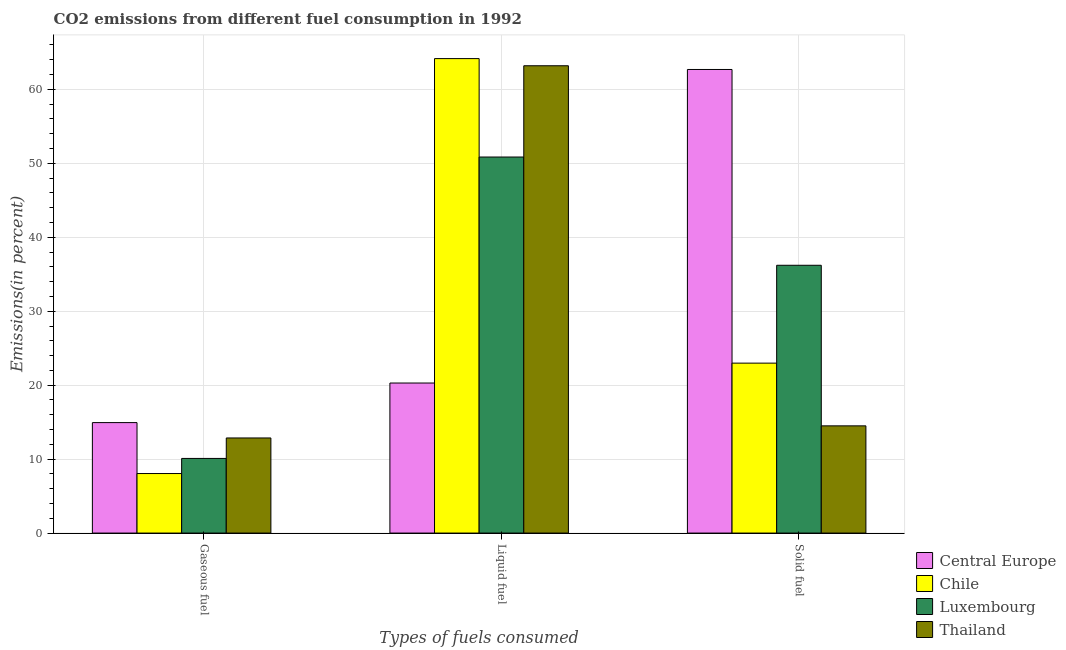How many different coloured bars are there?
Your response must be concise. 4. Are the number of bars per tick equal to the number of legend labels?
Your response must be concise. Yes. How many bars are there on the 2nd tick from the left?
Keep it short and to the point. 4. How many bars are there on the 3rd tick from the right?
Your answer should be compact. 4. What is the label of the 1st group of bars from the left?
Keep it short and to the point. Gaseous fuel. What is the percentage of solid fuel emission in Luxembourg?
Offer a very short reply. 36.21. Across all countries, what is the maximum percentage of gaseous fuel emission?
Make the answer very short. 14.94. Across all countries, what is the minimum percentage of solid fuel emission?
Offer a very short reply. 14.5. In which country was the percentage of gaseous fuel emission maximum?
Provide a succinct answer. Central Europe. In which country was the percentage of liquid fuel emission minimum?
Provide a succinct answer. Central Europe. What is the total percentage of liquid fuel emission in the graph?
Offer a terse response. 198.49. What is the difference between the percentage of solid fuel emission in Chile and that in Central Europe?
Offer a terse response. -39.71. What is the difference between the percentage of liquid fuel emission in Chile and the percentage of solid fuel emission in Thailand?
Give a very brief answer. 49.66. What is the average percentage of solid fuel emission per country?
Provide a short and direct response. 34.09. What is the difference between the percentage of liquid fuel emission and percentage of gaseous fuel emission in Chile?
Give a very brief answer. 56.11. In how many countries, is the percentage of solid fuel emission greater than 54 %?
Offer a terse response. 1. What is the ratio of the percentage of gaseous fuel emission in Chile to that in Central Europe?
Provide a short and direct response. 0.54. Is the percentage of liquid fuel emission in Chile less than that in Central Europe?
Offer a very short reply. No. What is the difference between the highest and the second highest percentage of solid fuel emission?
Offer a terse response. 26.48. What is the difference between the highest and the lowest percentage of gaseous fuel emission?
Provide a succinct answer. 6.89. Is the sum of the percentage of solid fuel emission in Luxembourg and Chile greater than the maximum percentage of gaseous fuel emission across all countries?
Offer a very short reply. Yes. What does the 1st bar from the left in Gaseous fuel represents?
Offer a terse response. Central Europe. What does the 4th bar from the right in Solid fuel represents?
Keep it short and to the point. Central Europe. Is it the case that in every country, the sum of the percentage of gaseous fuel emission and percentage of liquid fuel emission is greater than the percentage of solid fuel emission?
Your answer should be compact. No. How many countries are there in the graph?
Provide a succinct answer. 4. What is the difference between two consecutive major ticks on the Y-axis?
Provide a short and direct response. 10. Are the values on the major ticks of Y-axis written in scientific E-notation?
Your answer should be compact. No. Does the graph contain any zero values?
Provide a short and direct response. No. Does the graph contain grids?
Your answer should be very brief. Yes. Where does the legend appear in the graph?
Provide a succinct answer. Bottom right. How many legend labels are there?
Offer a very short reply. 4. How are the legend labels stacked?
Make the answer very short. Vertical. What is the title of the graph?
Offer a very short reply. CO2 emissions from different fuel consumption in 1992. Does "Ireland" appear as one of the legend labels in the graph?
Offer a very short reply. No. What is the label or title of the X-axis?
Make the answer very short. Types of fuels consumed. What is the label or title of the Y-axis?
Your response must be concise. Emissions(in percent). What is the Emissions(in percent) of Central Europe in Gaseous fuel?
Provide a succinct answer. 14.94. What is the Emissions(in percent) of Chile in Gaseous fuel?
Provide a short and direct response. 8.05. What is the Emissions(in percent) in Luxembourg in Gaseous fuel?
Provide a succinct answer. 10.09. What is the Emissions(in percent) in Thailand in Gaseous fuel?
Keep it short and to the point. 12.86. What is the Emissions(in percent) of Central Europe in Liquid fuel?
Ensure brevity in your answer.  20.29. What is the Emissions(in percent) in Chile in Liquid fuel?
Your answer should be very brief. 64.16. What is the Emissions(in percent) of Luxembourg in Liquid fuel?
Your answer should be compact. 50.85. What is the Emissions(in percent) of Thailand in Liquid fuel?
Keep it short and to the point. 63.19. What is the Emissions(in percent) in Central Europe in Solid fuel?
Your answer should be very brief. 62.69. What is the Emissions(in percent) in Chile in Solid fuel?
Offer a very short reply. 22.98. What is the Emissions(in percent) of Luxembourg in Solid fuel?
Ensure brevity in your answer.  36.21. What is the Emissions(in percent) of Thailand in Solid fuel?
Offer a terse response. 14.5. Across all Types of fuels consumed, what is the maximum Emissions(in percent) in Central Europe?
Your answer should be compact. 62.69. Across all Types of fuels consumed, what is the maximum Emissions(in percent) in Chile?
Offer a very short reply. 64.16. Across all Types of fuels consumed, what is the maximum Emissions(in percent) of Luxembourg?
Your answer should be compact. 50.85. Across all Types of fuels consumed, what is the maximum Emissions(in percent) in Thailand?
Your answer should be very brief. 63.19. Across all Types of fuels consumed, what is the minimum Emissions(in percent) in Central Europe?
Offer a very short reply. 14.94. Across all Types of fuels consumed, what is the minimum Emissions(in percent) in Chile?
Make the answer very short. 8.05. Across all Types of fuels consumed, what is the minimum Emissions(in percent) of Luxembourg?
Provide a succinct answer. 10.09. Across all Types of fuels consumed, what is the minimum Emissions(in percent) in Thailand?
Your answer should be compact. 12.86. What is the total Emissions(in percent) of Central Europe in the graph?
Provide a succinct answer. 97.92. What is the total Emissions(in percent) of Chile in the graph?
Your answer should be compact. 95.19. What is the total Emissions(in percent) in Luxembourg in the graph?
Make the answer very short. 97.16. What is the total Emissions(in percent) of Thailand in the graph?
Keep it short and to the point. 90.55. What is the difference between the Emissions(in percent) of Central Europe in Gaseous fuel and that in Liquid fuel?
Keep it short and to the point. -5.35. What is the difference between the Emissions(in percent) in Chile in Gaseous fuel and that in Liquid fuel?
Ensure brevity in your answer.  -56.11. What is the difference between the Emissions(in percent) in Luxembourg in Gaseous fuel and that in Liquid fuel?
Provide a succinct answer. -40.76. What is the difference between the Emissions(in percent) of Thailand in Gaseous fuel and that in Liquid fuel?
Your answer should be compact. -50.33. What is the difference between the Emissions(in percent) of Central Europe in Gaseous fuel and that in Solid fuel?
Offer a very short reply. -47.75. What is the difference between the Emissions(in percent) of Chile in Gaseous fuel and that in Solid fuel?
Provide a succinct answer. -14.93. What is the difference between the Emissions(in percent) in Luxembourg in Gaseous fuel and that in Solid fuel?
Provide a succinct answer. -26.12. What is the difference between the Emissions(in percent) of Thailand in Gaseous fuel and that in Solid fuel?
Make the answer very short. -1.64. What is the difference between the Emissions(in percent) in Central Europe in Liquid fuel and that in Solid fuel?
Keep it short and to the point. -42.4. What is the difference between the Emissions(in percent) in Chile in Liquid fuel and that in Solid fuel?
Make the answer very short. 41.18. What is the difference between the Emissions(in percent) of Luxembourg in Liquid fuel and that in Solid fuel?
Offer a terse response. 14.64. What is the difference between the Emissions(in percent) in Thailand in Liquid fuel and that in Solid fuel?
Provide a succinct answer. 48.69. What is the difference between the Emissions(in percent) in Central Europe in Gaseous fuel and the Emissions(in percent) in Chile in Liquid fuel?
Provide a succinct answer. -49.22. What is the difference between the Emissions(in percent) in Central Europe in Gaseous fuel and the Emissions(in percent) in Luxembourg in Liquid fuel?
Keep it short and to the point. -35.91. What is the difference between the Emissions(in percent) in Central Europe in Gaseous fuel and the Emissions(in percent) in Thailand in Liquid fuel?
Offer a very short reply. -48.25. What is the difference between the Emissions(in percent) in Chile in Gaseous fuel and the Emissions(in percent) in Luxembourg in Liquid fuel?
Your answer should be very brief. -42.8. What is the difference between the Emissions(in percent) in Chile in Gaseous fuel and the Emissions(in percent) in Thailand in Liquid fuel?
Provide a short and direct response. -55.14. What is the difference between the Emissions(in percent) of Luxembourg in Gaseous fuel and the Emissions(in percent) of Thailand in Liquid fuel?
Your answer should be very brief. -53.1. What is the difference between the Emissions(in percent) in Central Europe in Gaseous fuel and the Emissions(in percent) in Chile in Solid fuel?
Provide a succinct answer. -8.04. What is the difference between the Emissions(in percent) in Central Europe in Gaseous fuel and the Emissions(in percent) in Luxembourg in Solid fuel?
Keep it short and to the point. -21.27. What is the difference between the Emissions(in percent) in Central Europe in Gaseous fuel and the Emissions(in percent) in Thailand in Solid fuel?
Offer a terse response. 0.44. What is the difference between the Emissions(in percent) in Chile in Gaseous fuel and the Emissions(in percent) in Luxembourg in Solid fuel?
Keep it short and to the point. -28.16. What is the difference between the Emissions(in percent) in Chile in Gaseous fuel and the Emissions(in percent) in Thailand in Solid fuel?
Offer a very short reply. -6.45. What is the difference between the Emissions(in percent) in Luxembourg in Gaseous fuel and the Emissions(in percent) in Thailand in Solid fuel?
Provide a short and direct response. -4.4. What is the difference between the Emissions(in percent) of Central Europe in Liquid fuel and the Emissions(in percent) of Chile in Solid fuel?
Offer a very short reply. -2.69. What is the difference between the Emissions(in percent) in Central Europe in Liquid fuel and the Emissions(in percent) in Luxembourg in Solid fuel?
Provide a short and direct response. -15.92. What is the difference between the Emissions(in percent) in Central Europe in Liquid fuel and the Emissions(in percent) in Thailand in Solid fuel?
Your answer should be compact. 5.79. What is the difference between the Emissions(in percent) in Chile in Liquid fuel and the Emissions(in percent) in Luxembourg in Solid fuel?
Offer a very short reply. 27.95. What is the difference between the Emissions(in percent) of Chile in Liquid fuel and the Emissions(in percent) of Thailand in Solid fuel?
Ensure brevity in your answer.  49.66. What is the difference between the Emissions(in percent) of Luxembourg in Liquid fuel and the Emissions(in percent) of Thailand in Solid fuel?
Your answer should be very brief. 36.35. What is the average Emissions(in percent) in Central Europe per Types of fuels consumed?
Offer a very short reply. 32.64. What is the average Emissions(in percent) in Chile per Types of fuels consumed?
Your answer should be compact. 31.73. What is the average Emissions(in percent) of Luxembourg per Types of fuels consumed?
Provide a succinct answer. 32.39. What is the average Emissions(in percent) of Thailand per Types of fuels consumed?
Your answer should be very brief. 30.18. What is the difference between the Emissions(in percent) of Central Europe and Emissions(in percent) of Chile in Gaseous fuel?
Make the answer very short. 6.89. What is the difference between the Emissions(in percent) in Central Europe and Emissions(in percent) in Luxembourg in Gaseous fuel?
Provide a succinct answer. 4.84. What is the difference between the Emissions(in percent) in Central Europe and Emissions(in percent) in Thailand in Gaseous fuel?
Your response must be concise. 2.08. What is the difference between the Emissions(in percent) of Chile and Emissions(in percent) of Luxembourg in Gaseous fuel?
Your response must be concise. -2.04. What is the difference between the Emissions(in percent) in Chile and Emissions(in percent) in Thailand in Gaseous fuel?
Your answer should be compact. -4.81. What is the difference between the Emissions(in percent) in Luxembourg and Emissions(in percent) in Thailand in Gaseous fuel?
Your response must be concise. -2.77. What is the difference between the Emissions(in percent) of Central Europe and Emissions(in percent) of Chile in Liquid fuel?
Give a very brief answer. -43.87. What is the difference between the Emissions(in percent) of Central Europe and Emissions(in percent) of Luxembourg in Liquid fuel?
Your answer should be compact. -30.56. What is the difference between the Emissions(in percent) of Central Europe and Emissions(in percent) of Thailand in Liquid fuel?
Provide a short and direct response. -42.9. What is the difference between the Emissions(in percent) of Chile and Emissions(in percent) of Luxembourg in Liquid fuel?
Your answer should be very brief. 13.31. What is the difference between the Emissions(in percent) in Chile and Emissions(in percent) in Thailand in Liquid fuel?
Your response must be concise. 0.97. What is the difference between the Emissions(in percent) of Luxembourg and Emissions(in percent) of Thailand in Liquid fuel?
Your answer should be compact. -12.34. What is the difference between the Emissions(in percent) in Central Europe and Emissions(in percent) in Chile in Solid fuel?
Offer a terse response. 39.71. What is the difference between the Emissions(in percent) of Central Europe and Emissions(in percent) of Luxembourg in Solid fuel?
Your answer should be compact. 26.48. What is the difference between the Emissions(in percent) of Central Europe and Emissions(in percent) of Thailand in Solid fuel?
Provide a short and direct response. 48.19. What is the difference between the Emissions(in percent) in Chile and Emissions(in percent) in Luxembourg in Solid fuel?
Keep it short and to the point. -13.23. What is the difference between the Emissions(in percent) of Chile and Emissions(in percent) of Thailand in Solid fuel?
Ensure brevity in your answer.  8.48. What is the difference between the Emissions(in percent) of Luxembourg and Emissions(in percent) of Thailand in Solid fuel?
Make the answer very short. 21.71. What is the ratio of the Emissions(in percent) in Central Europe in Gaseous fuel to that in Liquid fuel?
Your answer should be compact. 0.74. What is the ratio of the Emissions(in percent) of Chile in Gaseous fuel to that in Liquid fuel?
Provide a succinct answer. 0.13. What is the ratio of the Emissions(in percent) of Luxembourg in Gaseous fuel to that in Liquid fuel?
Your answer should be compact. 0.2. What is the ratio of the Emissions(in percent) in Thailand in Gaseous fuel to that in Liquid fuel?
Provide a succinct answer. 0.2. What is the ratio of the Emissions(in percent) of Central Europe in Gaseous fuel to that in Solid fuel?
Make the answer very short. 0.24. What is the ratio of the Emissions(in percent) in Chile in Gaseous fuel to that in Solid fuel?
Provide a succinct answer. 0.35. What is the ratio of the Emissions(in percent) of Luxembourg in Gaseous fuel to that in Solid fuel?
Offer a very short reply. 0.28. What is the ratio of the Emissions(in percent) of Thailand in Gaseous fuel to that in Solid fuel?
Your answer should be very brief. 0.89. What is the ratio of the Emissions(in percent) of Central Europe in Liquid fuel to that in Solid fuel?
Give a very brief answer. 0.32. What is the ratio of the Emissions(in percent) of Chile in Liquid fuel to that in Solid fuel?
Your answer should be compact. 2.79. What is the ratio of the Emissions(in percent) in Luxembourg in Liquid fuel to that in Solid fuel?
Your response must be concise. 1.4. What is the ratio of the Emissions(in percent) in Thailand in Liquid fuel to that in Solid fuel?
Ensure brevity in your answer.  4.36. What is the difference between the highest and the second highest Emissions(in percent) of Central Europe?
Ensure brevity in your answer.  42.4. What is the difference between the highest and the second highest Emissions(in percent) of Chile?
Your answer should be very brief. 41.18. What is the difference between the highest and the second highest Emissions(in percent) of Luxembourg?
Your answer should be very brief. 14.64. What is the difference between the highest and the second highest Emissions(in percent) of Thailand?
Keep it short and to the point. 48.69. What is the difference between the highest and the lowest Emissions(in percent) in Central Europe?
Your response must be concise. 47.75. What is the difference between the highest and the lowest Emissions(in percent) in Chile?
Make the answer very short. 56.11. What is the difference between the highest and the lowest Emissions(in percent) of Luxembourg?
Offer a terse response. 40.76. What is the difference between the highest and the lowest Emissions(in percent) in Thailand?
Make the answer very short. 50.33. 